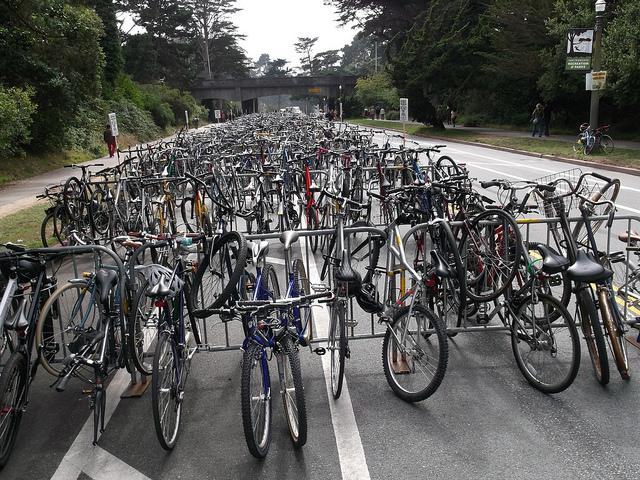What type of transportation is shown? bike 